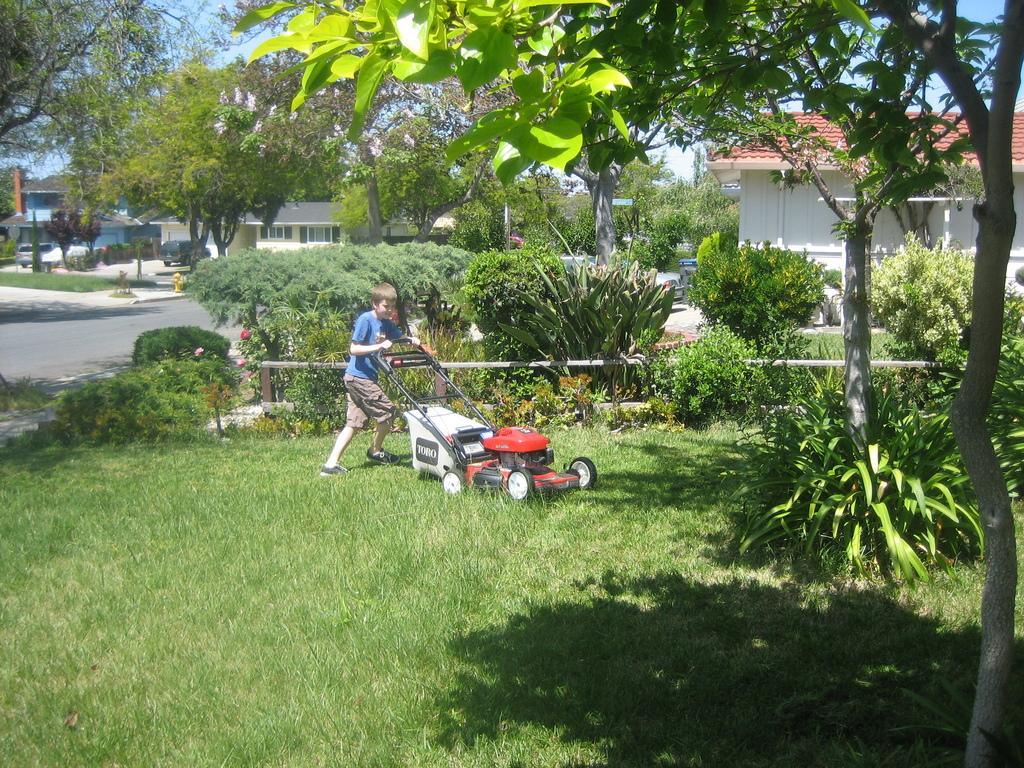Who is the main subject in the image? There is a boy in the image. What is the boy holding in the image? The boy is holding a grass-cutting machine. What can be seen in the background of the image? There are trees, a road, vehicles, houses, plants, and the sky visible in the background of the image. What type of lunch does the boy's team usually have after their hobbies? There is no information about the boy's lunch, team, or hobbies in the image, so it cannot be determined from the image. 